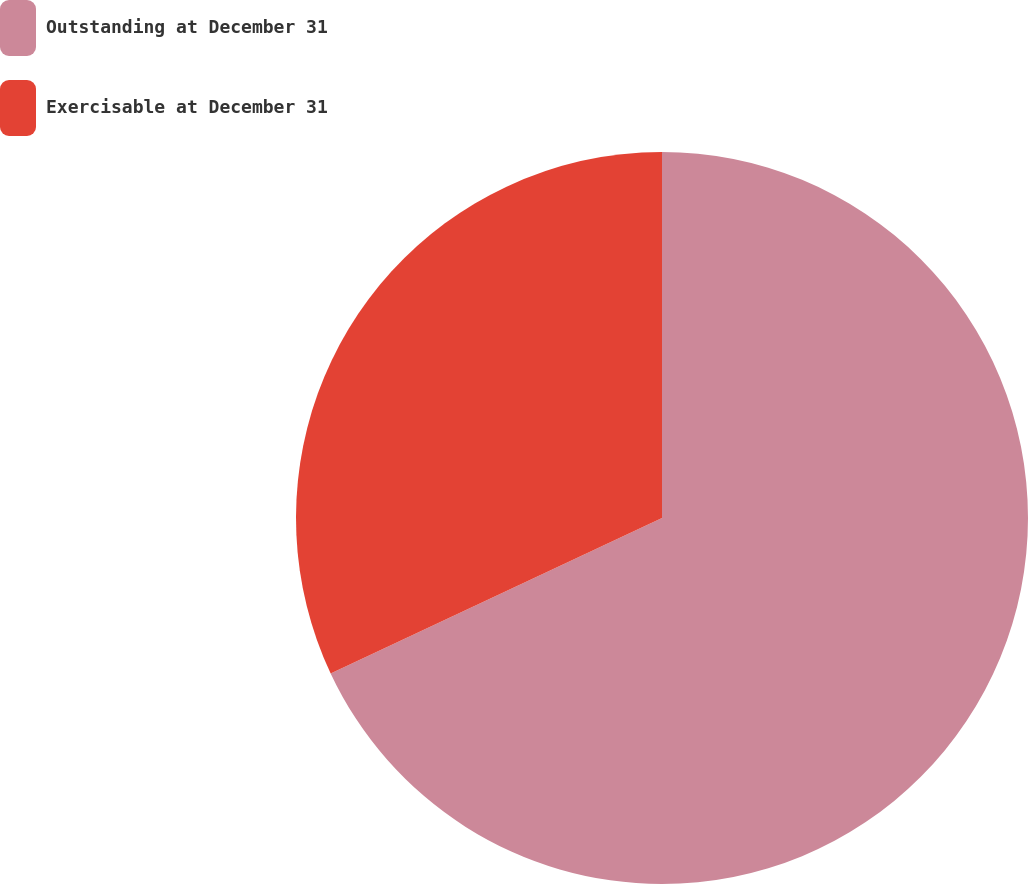<chart> <loc_0><loc_0><loc_500><loc_500><pie_chart><fcel>Outstanding at December 31<fcel>Exercisable at December 31<nl><fcel>68.02%<fcel>31.98%<nl></chart> 